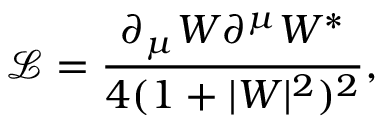<formula> <loc_0><loc_0><loc_500><loc_500>\mathcal { L } = \frac { \partial _ { \mu } W \partial ^ { \mu } W ^ { * } } { 4 ( 1 + | W | ^ { 2 } ) ^ { 2 } } ,</formula> 